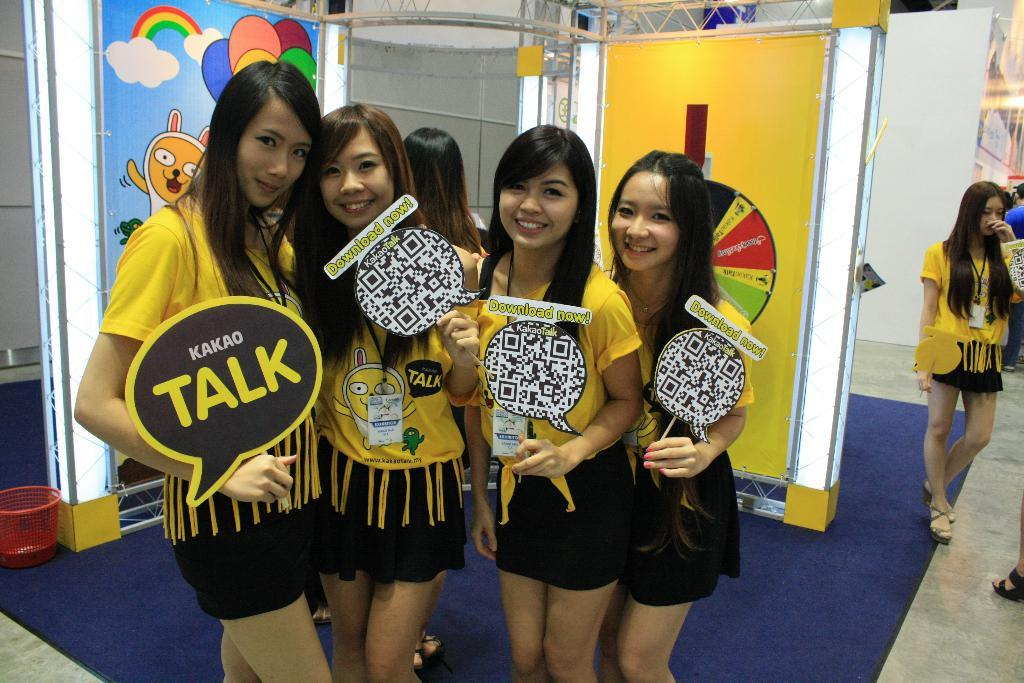<image>
Share a concise interpretation of the image provided. girls promoting kakao talk with signs to download now 